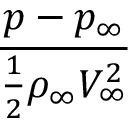<formula> <loc_0><loc_0><loc_500><loc_500>\frac { p - p _ { \infty } } { \frac { 1 } { 2 } \rho _ { \infty } V _ { \infty } ^ { 2 } }</formula> 